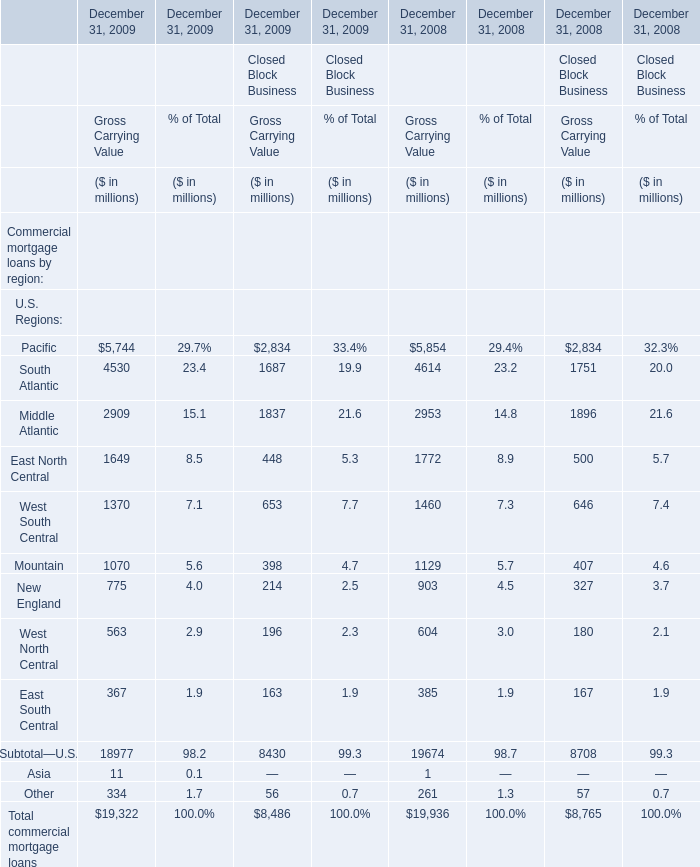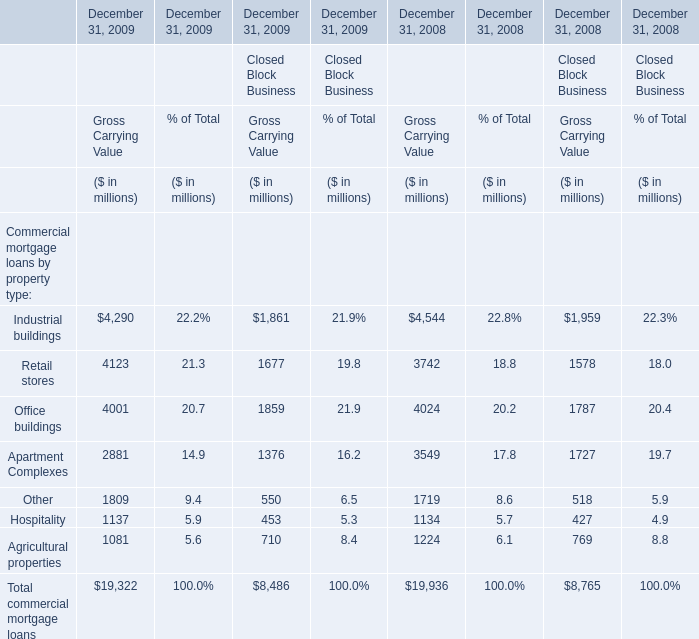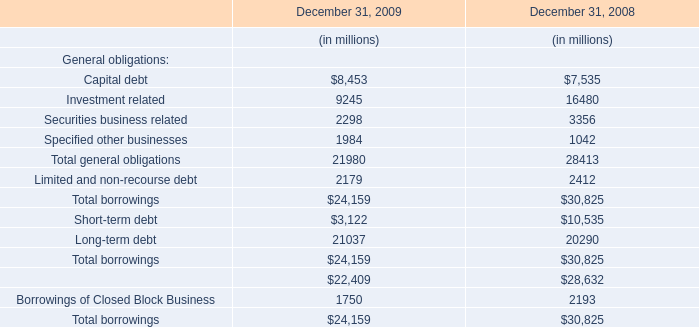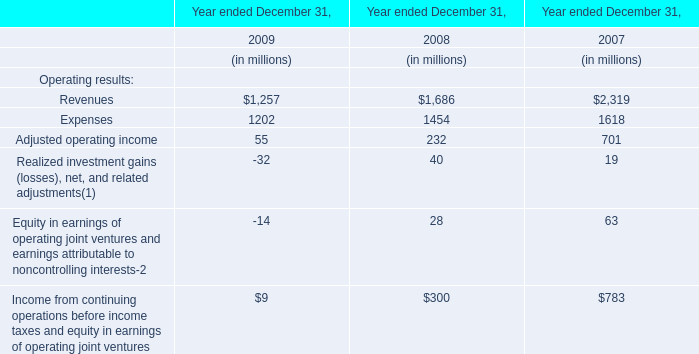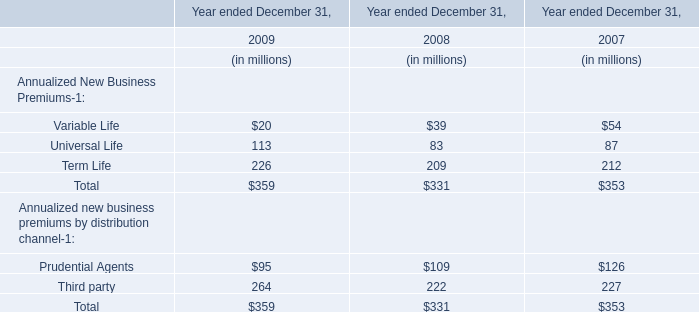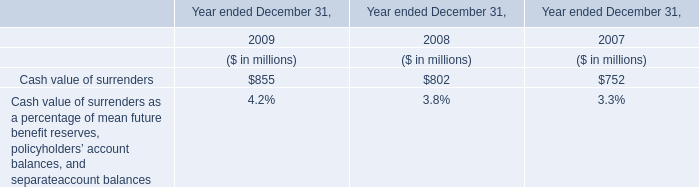What's the total value of all for Gross Carrying Value of Financial Services Businesses that are smaller than 500 in 2009? (in million) 
Computations: ((11 + 367) + 334)
Answer: 712.0. 